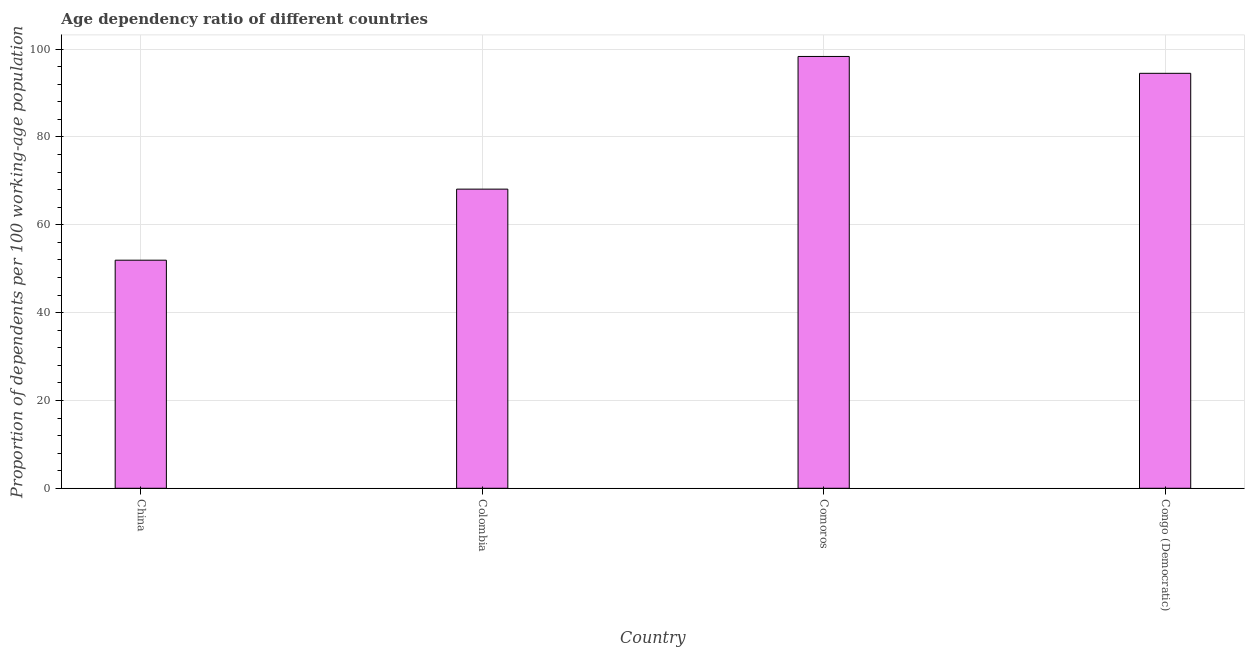Does the graph contain any zero values?
Your answer should be compact. No. What is the title of the graph?
Offer a terse response. Age dependency ratio of different countries. What is the label or title of the Y-axis?
Provide a short and direct response. Proportion of dependents per 100 working-age population. What is the age dependency ratio in China?
Ensure brevity in your answer.  51.94. Across all countries, what is the maximum age dependency ratio?
Keep it short and to the point. 98.33. Across all countries, what is the minimum age dependency ratio?
Provide a short and direct response. 51.94. In which country was the age dependency ratio maximum?
Keep it short and to the point. Comoros. In which country was the age dependency ratio minimum?
Ensure brevity in your answer.  China. What is the sum of the age dependency ratio?
Give a very brief answer. 312.88. What is the difference between the age dependency ratio in Colombia and Comoros?
Your answer should be very brief. -30.21. What is the average age dependency ratio per country?
Your answer should be very brief. 78.22. What is the median age dependency ratio?
Keep it short and to the point. 81.31. In how many countries, is the age dependency ratio greater than 16 ?
Make the answer very short. 4. What is the ratio of the age dependency ratio in China to that in Comoros?
Your answer should be compact. 0.53. Is the age dependency ratio in China less than that in Congo (Democratic)?
Your answer should be compact. Yes. What is the difference between the highest and the second highest age dependency ratio?
Keep it short and to the point. 3.84. What is the difference between the highest and the lowest age dependency ratio?
Provide a succinct answer. 46.39. What is the Proportion of dependents per 100 working-age population in China?
Provide a succinct answer. 51.94. What is the Proportion of dependents per 100 working-age population in Colombia?
Your response must be concise. 68.12. What is the Proportion of dependents per 100 working-age population of Comoros?
Ensure brevity in your answer.  98.33. What is the Proportion of dependents per 100 working-age population of Congo (Democratic)?
Provide a succinct answer. 94.49. What is the difference between the Proportion of dependents per 100 working-age population in China and Colombia?
Ensure brevity in your answer.  -16.18. What is the difference between the Proportion of dependents per 100 working-age population in China and Comoros?
Offer a terse response. -46.39. What is the difference between the Proportion of dependents per 100 working-age population in China and Congo (Democratic)?
Ensure brevity in your answer.  -42.55. What is the difference between the Proportion of dependents per 100 working-age population in Colombia and Comoros?
Offer a terse response. -30.21. What is the difference between the Proportion of dependents per 100 working-age population in Colombia and Congo (Democratic)?
Provide a succinct answer. -26.37. What is the difference between the Proportion of dependents per 100 working-age population in Comoros and Congo (Democratic)?
Keep it short and to the point. 3.84. What is the ratio of the Proportion of dependents per 100 working-age population in China to that in Colombia?
Your answer should be very brief. 0.76. What is the ratio of the Proportion of dependents per 100 working-age population in China to that in Comoros?
Ensure brevity in your answer.  0.53. What is the ratio of the Proportion of dependents per 100 working-age population in China to that in Congo (Democratic)?
Offer a terse response. 0.55. What is the ratio of the Proportion of dependents per 100 working-age population in Colombia to that in Comoros?
Your answer should be very brief. 0.69. What is the ratio of the Proportion of dependents per 100 working-age population in Colombia to that in Congo (Democratic)?
Ensure brevity in your answer.  0.72. What is the ratio of the Proportion of dependents per 100 working-age population in Comoros to that in Congo (Democratic)?
Your answer should be very brief. 1.04. 